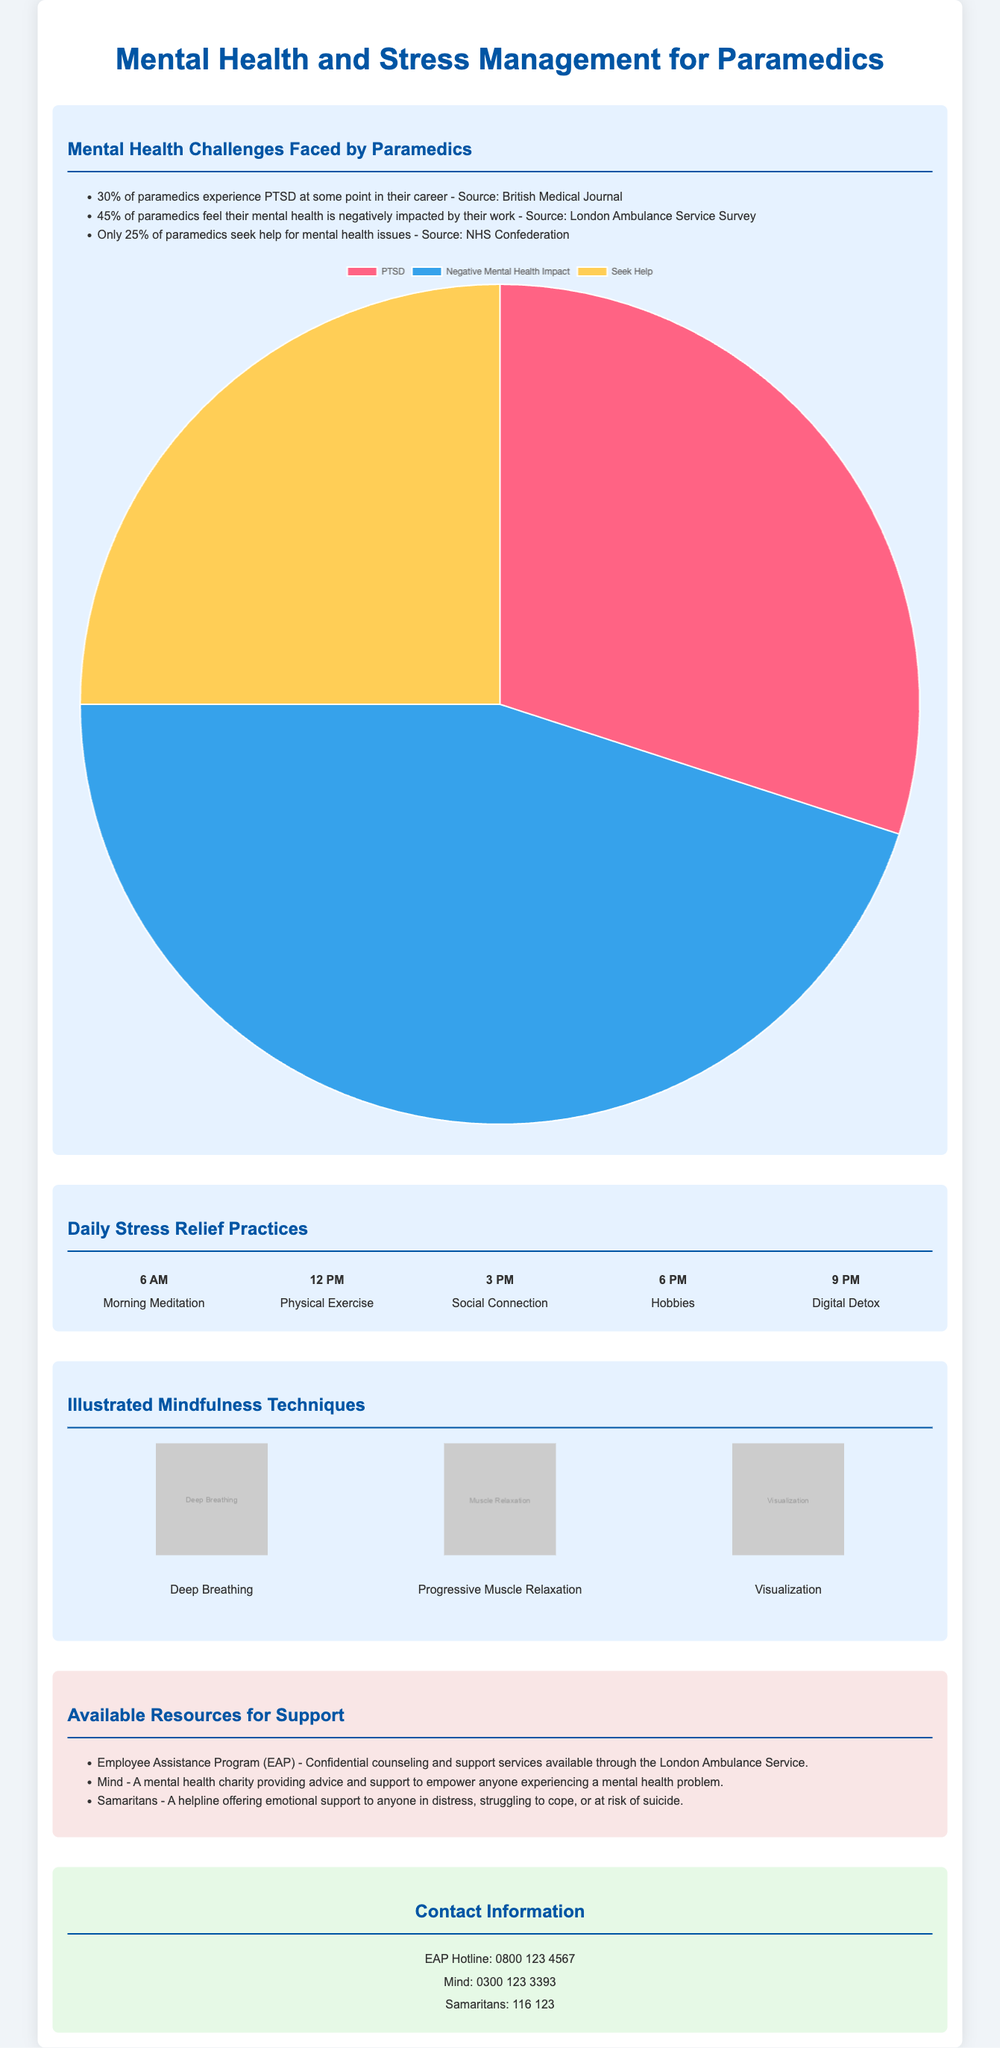What percentage of paramedics experience PTSD? The document states that 30% of paramedics experience PTSD at some point in their career according to the British Medical Journal.
Answer: 30% What is the helpline number for Samaritans? The contact information section provides the helpline number for Samaritans as 116 123.
Answer: 116 123 What percentage of paramedics feel their mental health is negatively impacted by their work? The document states that 45% of paramedics report their mental health is negatively impacted by their work as per the London Ambulance Service Survey.
Answer: 45% What is one of the daily stress relief practices listed at 3 PM? The infographic lists Social Connection as a daily stress relief practice at 3 PM.
Answer: Social Connection What resources are available for mental health support? The document lists Employee Assistance Program, Mind, and Samaritans as resources for support.
Answer: Employee Assistance Program, Mind, Samaritans What mindfulness technique includes 'Deep Breathing'? Deep Breathing is one of the illustrated mindfulness techniques mentioned in the infographic.
Answer: Deep Breathing How many paramedics seek help for mental health issues? The document indicates that only 25% of paramedics seek help for mental health issues based on the NHS Confederation data.
Answer: 25% What color is used to represent PTSD in the mental health chart? In the pie chart, PTSD is represented by the color #FF6384.
Answer: #FF6384 What time is scheduled for hobbies as a stress relief practice? The infographic schedules hobbies as a stress relief practice at 6 PM.
Answer: 6 PM 